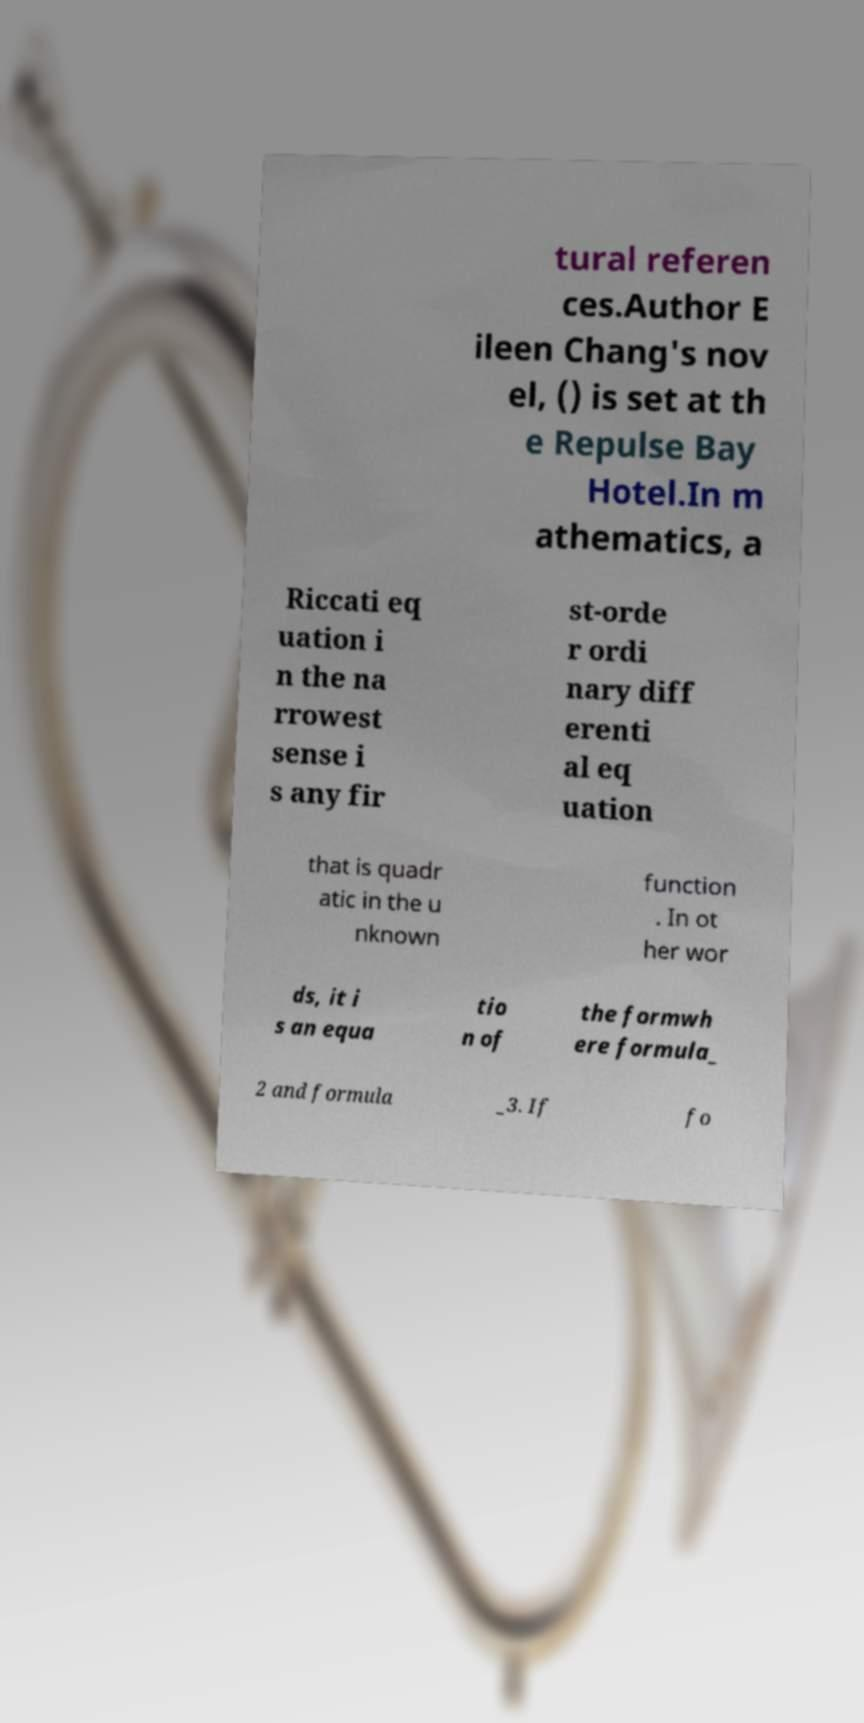Could you assist in decoding the text presented in this image and type it out clearly? tural referen ces.Author E ileen Chang's nov el, () is set at th e Repulse Bay Hotel.In m athematics, a Riccati eq uation i n the na rrowest sense i s any fir st-orde r ordi nary diff erenti al eq uation that is quadr atic in the u nknown function . In ot her wor ds, it i s an equa tio n of the formwh ere formula_ 2 and formula _3. If fo 